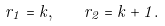Convert formula to latex. <formula><loc_0><loc_0><loc_500><loc_500>r _ { 1 } = k , \quad r _ { 2 } = k + 1 .</formula> 